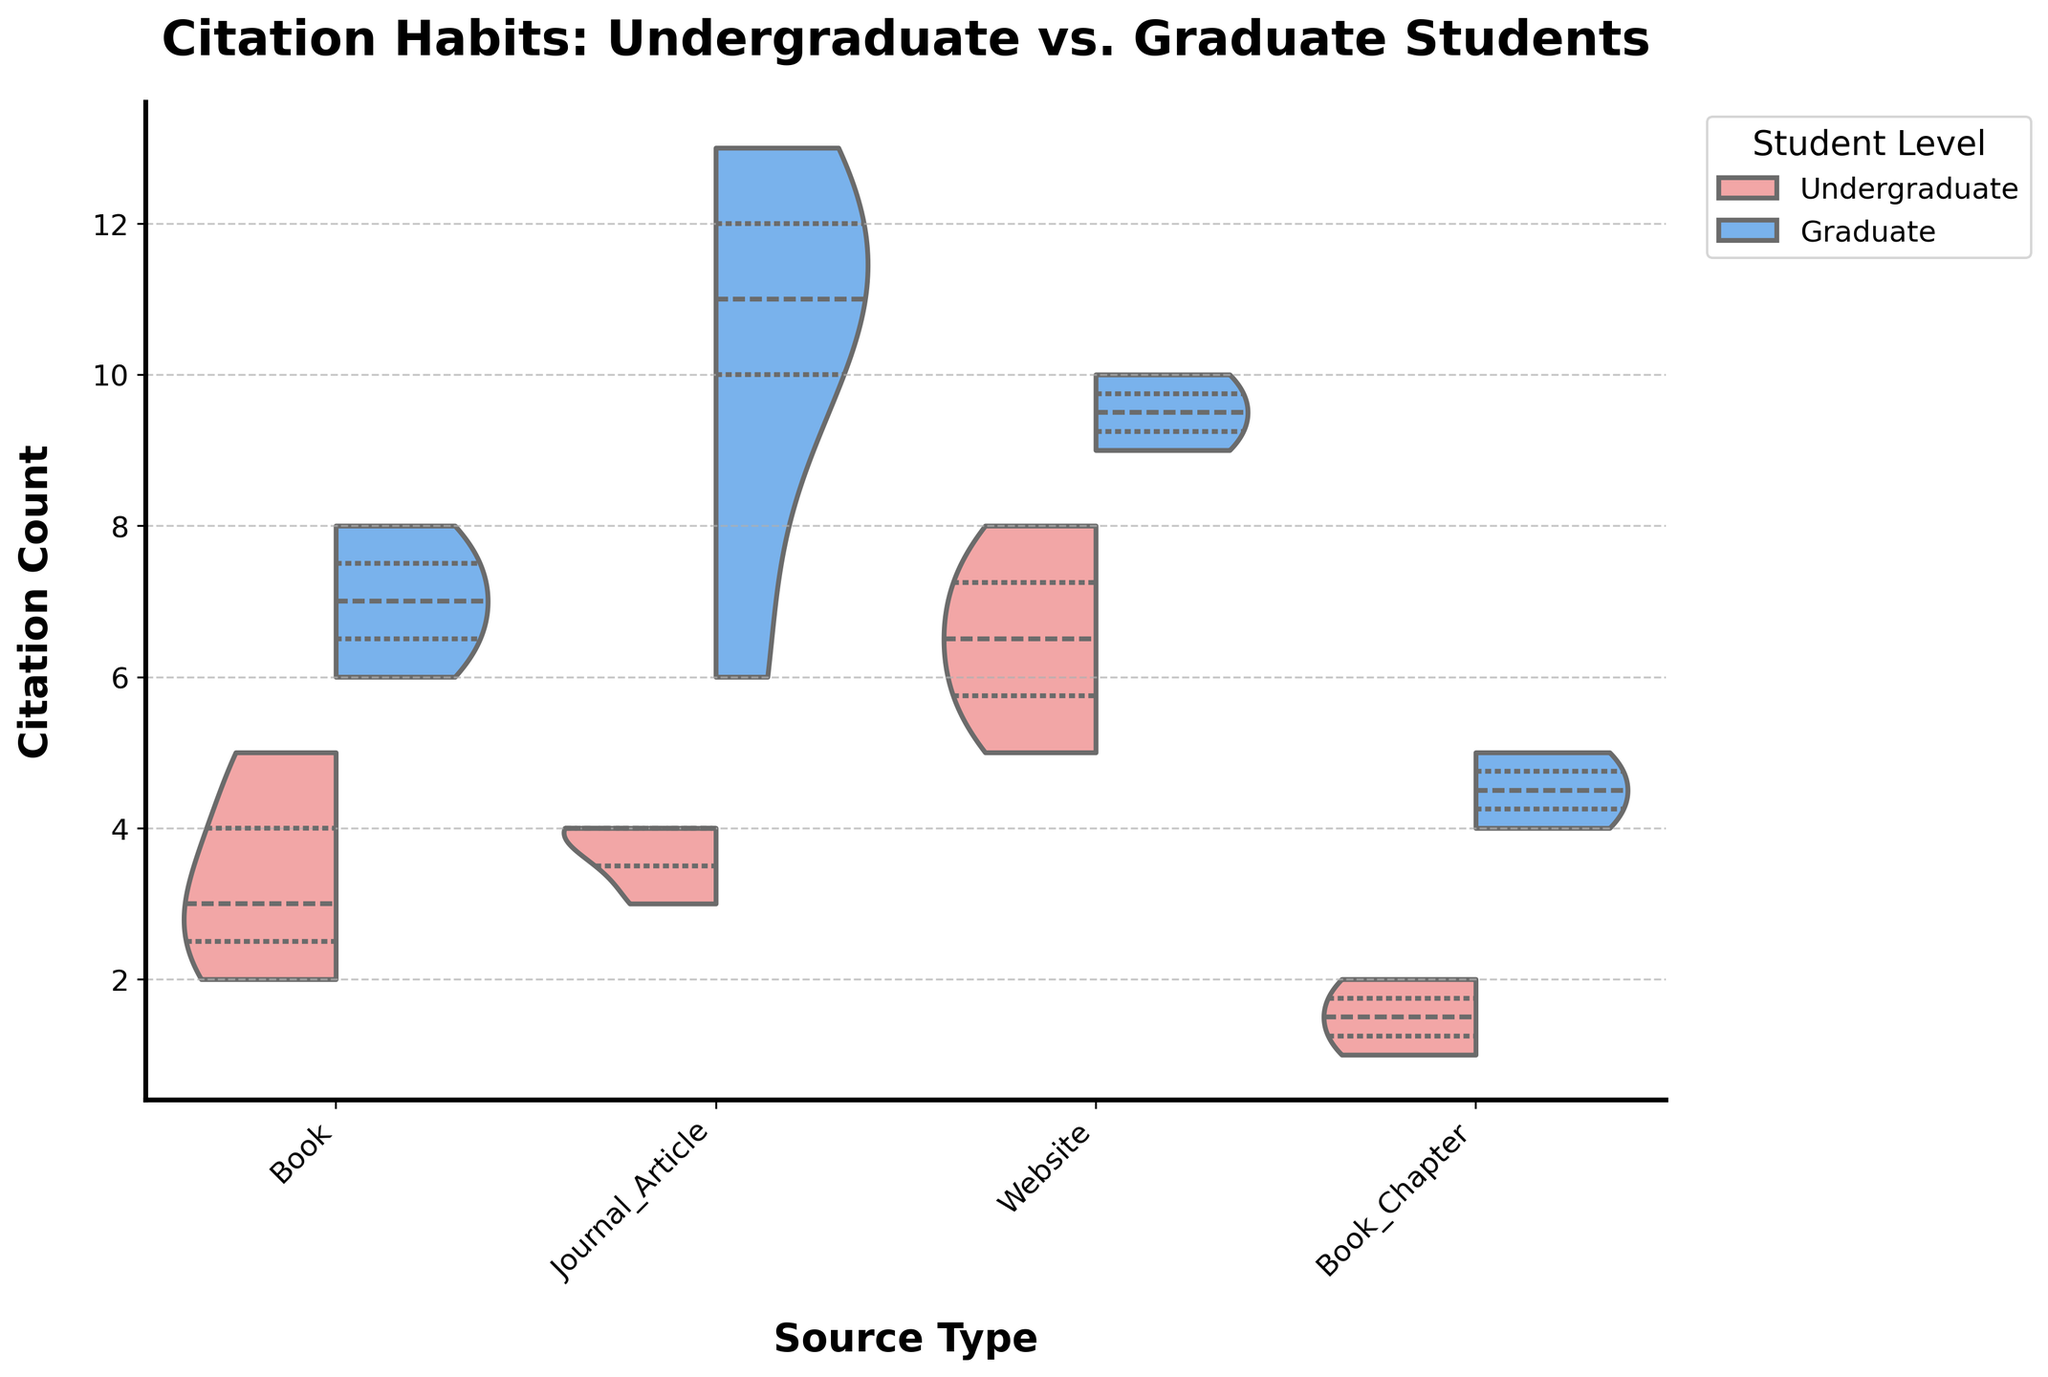What is the title of the figure? The title is located at the top of the figure. It is prominently displayed with a larger font size and bold formatting.
Answer: Citation Habits: Undergraduate vs. Graduate Students What’s the range of citation counts for undergraduate students? The citation counts for undergraduate students can be observed by looking at the length of the violin plots for undergraduate students for each source type.
Answer: 1 to 8 citations Which student level cites journals more frequently? By comparing the two halves of the violin plot for 'Journal_Article', we can see which half stretches further along the y-axis (citation count).
Answer: Graduate students What’s the median citation count for graduate students using journal articles? In a violin plot with quartiles marked, the median is shown as the central line in the respective half. For 'Journal_Article', observe the median line in the graduate-student half.
Answer: 10 citations Do undergraduate students cite journal articles more frequently than books? Compare the size and spread of the violin plots for 'Journal_Article' and 'Book' under the undergraduate section.
Answer: Yes What is the average citation count for undergraduate students using websites? To find the average, we consider the half-violin plot for 'Website' undergraduates and estimate citation counts. The average for undergraduate website citations should be around the central tendency of their plot, which appears roughly mid-range.
Answer: Approximately 6 citations Which source type has the widest range of citation counts for graduate students? Check the spread (minimum to maximum) of the half-violin plots for graduate students across the different source types and find the one with the largest spread.
Answer: Journal_Article Is the citation count distribution for graduate students in 'Book_Chapter' sources more skewed or more symmetrical? Look at the shape of the graduate students’ half-violin plot for 'Book_Chapter'. A skewed plot will be imbalanced and asymmetric, while a symmetrical plot will be even on both sides.
Answer: Symmetrical What percentage of citations by graduate students for 'Journal_Article' exceeds 10 citations? Observe the density and distribution above the 10-citation line in the graduate student half-violin plot for 'Journal_Article'. Since there are more data points concentrated at and above 10, it would be a significant percentage.
Answer: Approximately 50% Which source type shows the least difference in citation habits between undergraduate and graduate students? By comparing the overlap and shape of the violin plots for both student levels across all source types, 'Book' and 'Website' display narrower differences.
Answer: Website 